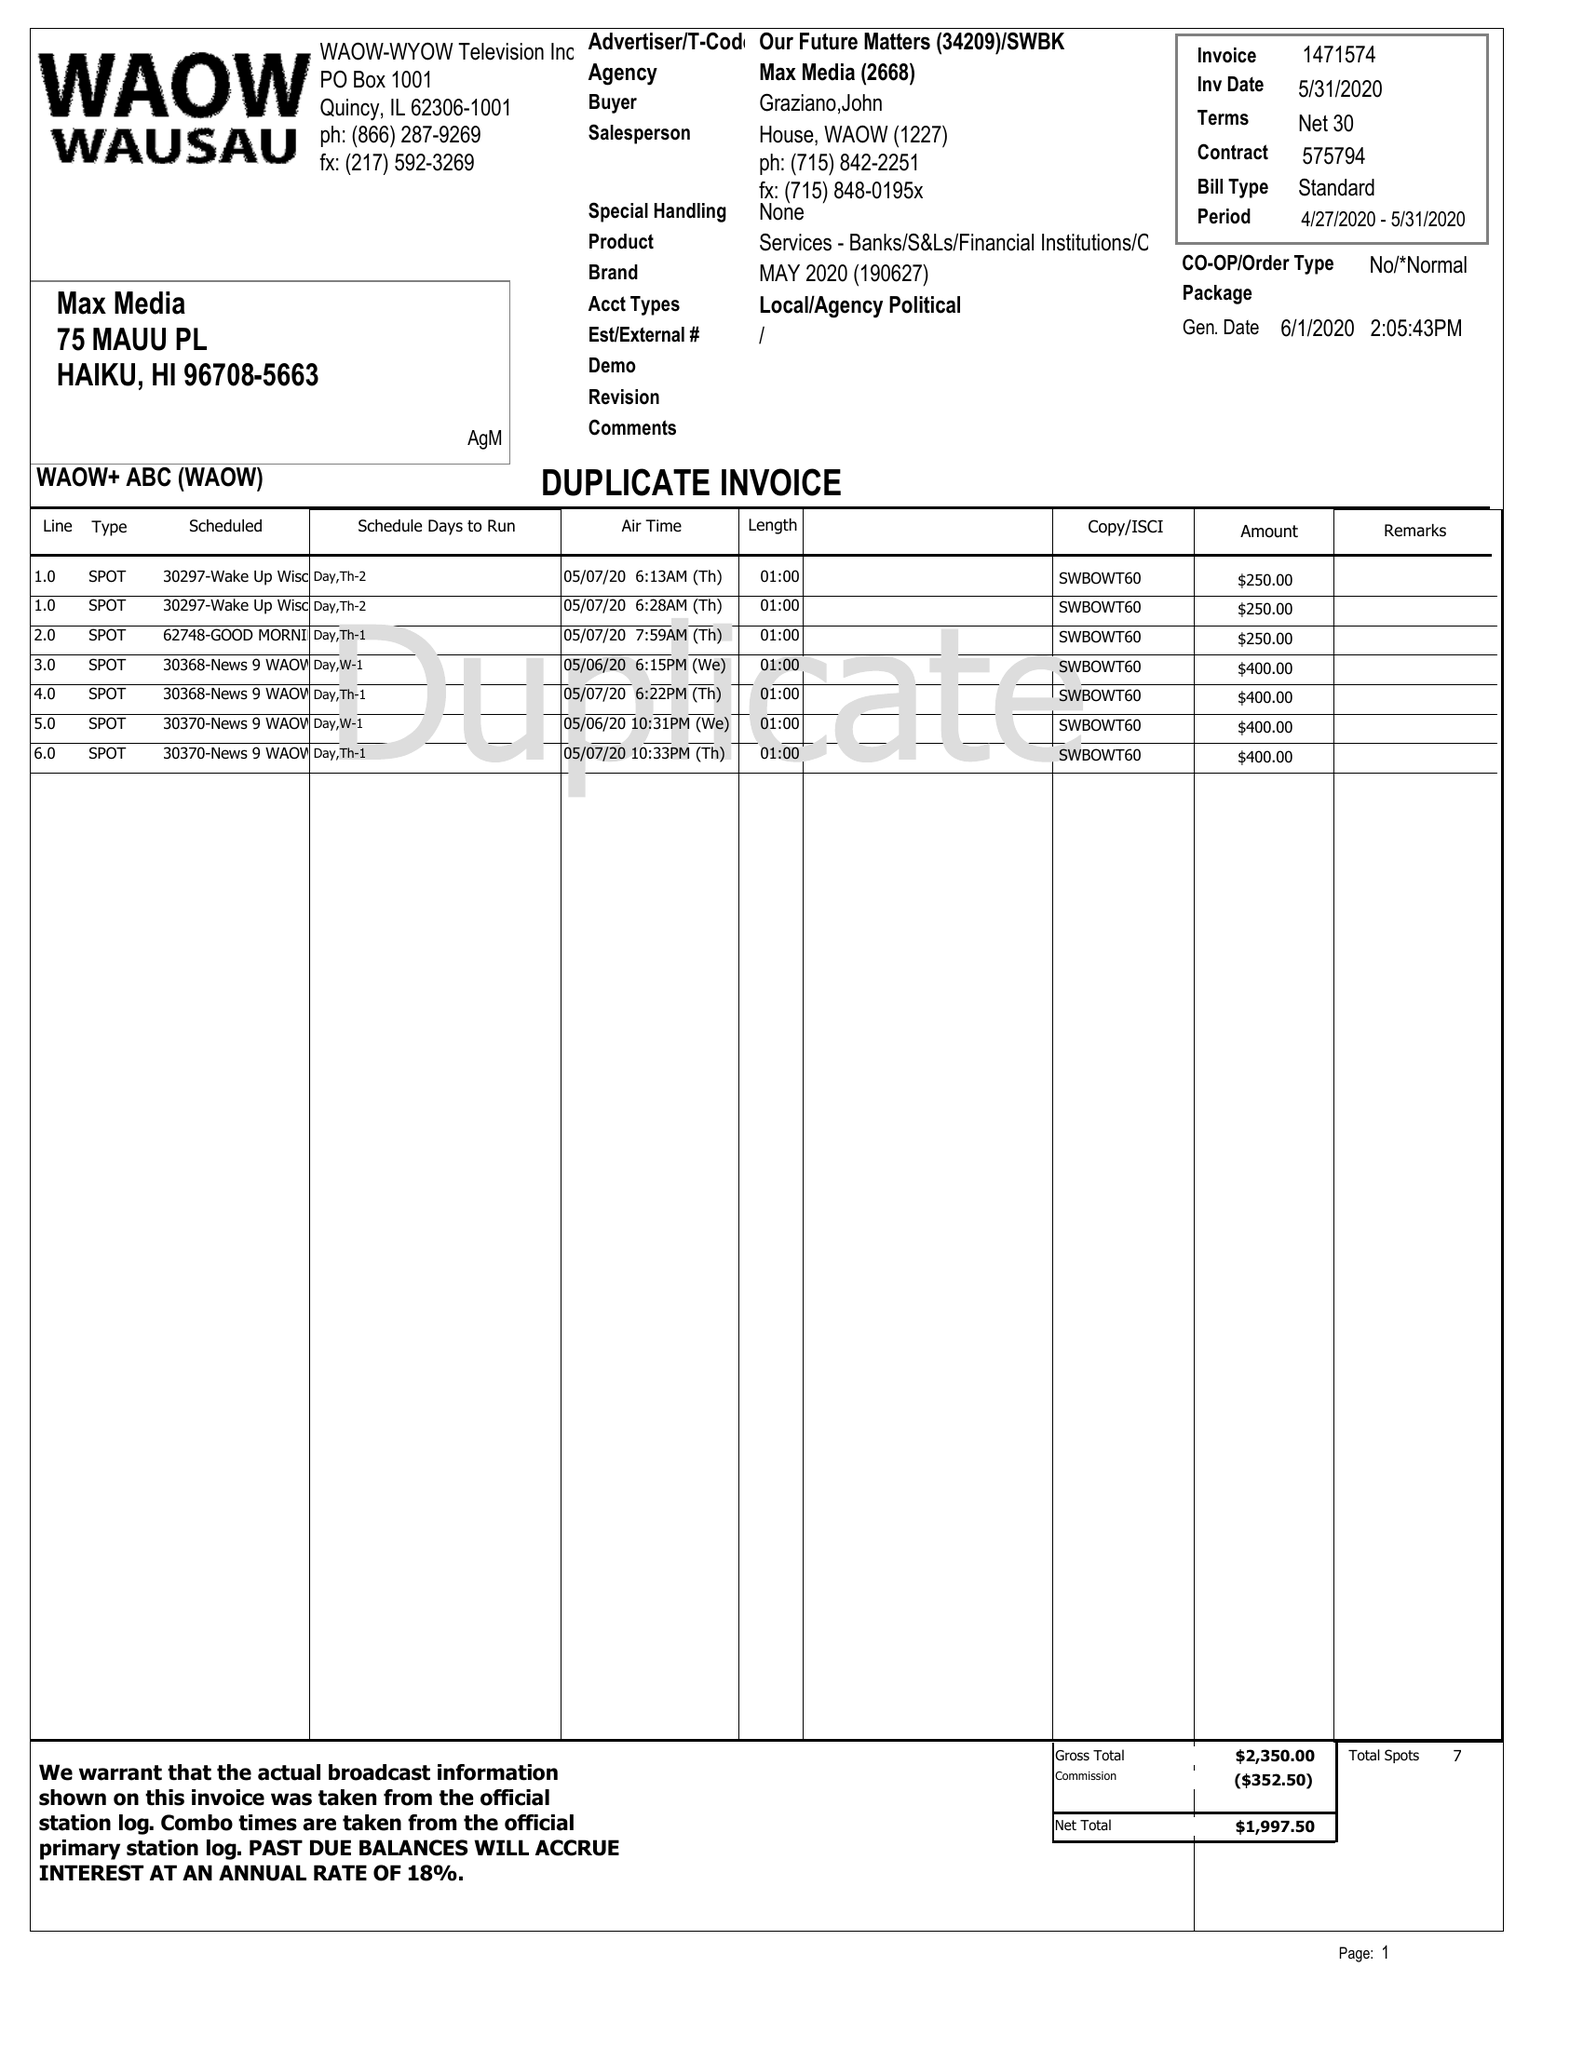What is the value for the flight_to?
Answer the question using a single word or phrase. 05/31/20 